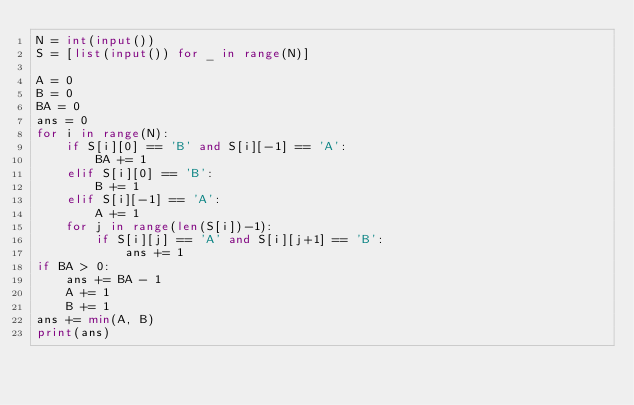<code> <loc_0><loc_0><loc_500><loc_500><_Python_>N = int(input())
S = [list(input()) for _ in range(N)]

A = 0
B = 0
BA = 0
ans = 0
for i in range(N):
    if S[i][0] == 'B' and S[i][-1] == 'A':
        BA += 1
    elif S[i][0] == 'B':
        B += 1
    elif S[i][-1] == 'A':
        A += 1
    for j in range(len(S[i])-1):
        if S[i][j] == 'A' and S[i][j+1] == 'B':
            ans += 1
if BA > 0:
    ans += BA - 1
    A += 1
    B += 1
ans += min(A, B)
print(ans)
</code> 